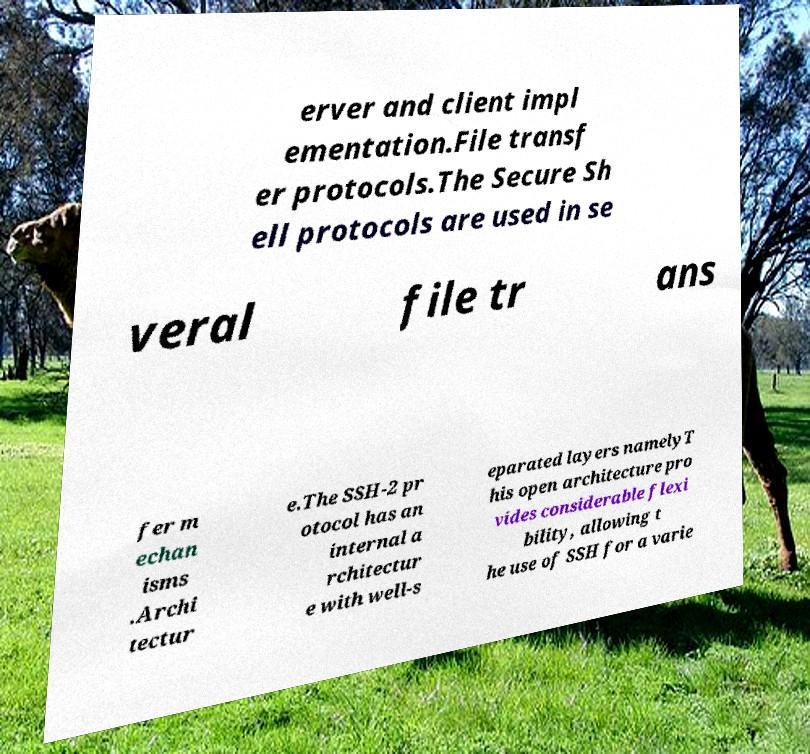Can you accurately transcribe the text from the provided image for me? erver and client impl ementation.File transf er protocols.The Secure Sh ell protocols are used in se veral file tr ans fer m echan isms .Archi tectur e.The SSH-2 pr otocol has an internal a rchitectur e with well-s eparated layers namelyT his open architecture pro vides considerable flexi bility, allowing t he use of SSH for a varie 